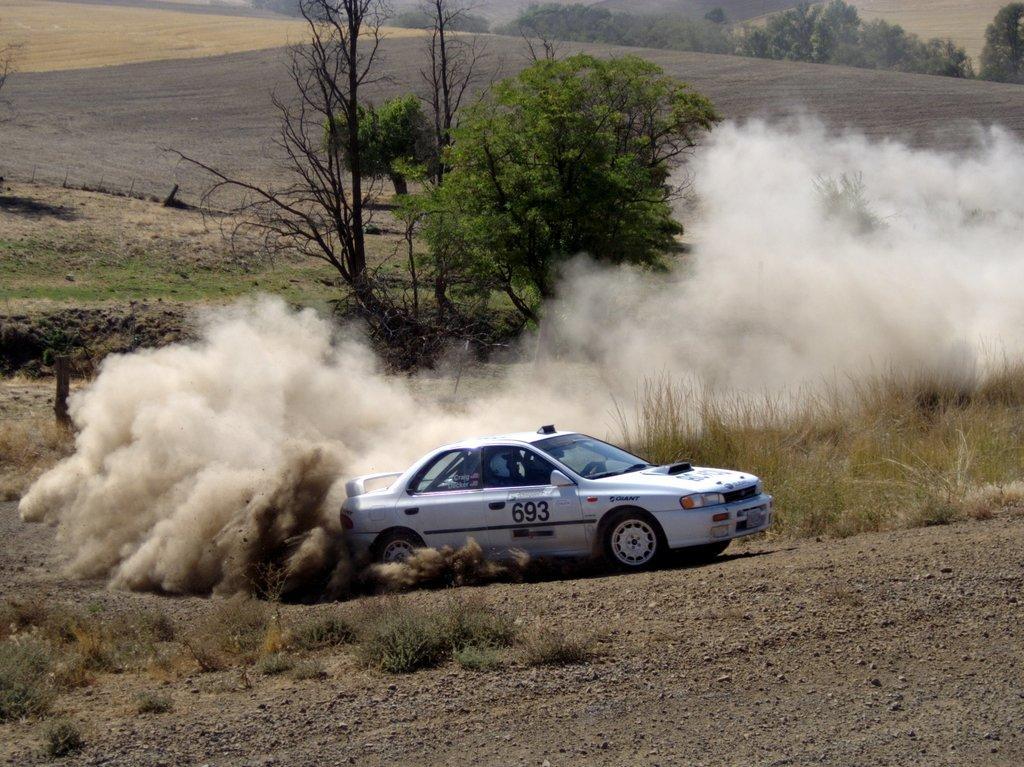Describe this image in one or two sentences. In this picture there is a man who is riding a white car. Backside of the car we can see dust and smoke. In the background we can see farmland, mountain and trees. In the bottom left corner we can see the grass. 